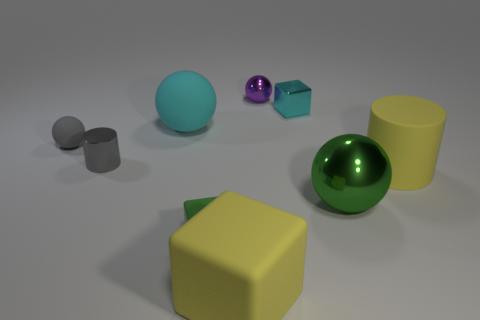Subtract 1 spheres. How many spheres are left? 3 Add 1 rubber spheres. How many objects exist? 10 Subtract all blocks. How many objects are left? 6 Subtract 0 red spheres. How many objects are left? 9 Subtract all big blocks. Subtract all yellow blocks. How many objects are left? 7 Add 6 large green things. How many large green things are left? 7 Add 2 cyan balls. How many cyan balls exist? 3 